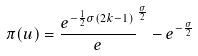<formula> <loc_0><loc_0><loc_500><loc_500>\pi ( u ) = \frac { e ^ { - \frac { 1 } { 2 } \sigma ( 2 k - 1 ) } } e ^ { \frac { \sigma } { 2 } } - e ^ { - \frac { \sigma } { 2 } }</formula> 